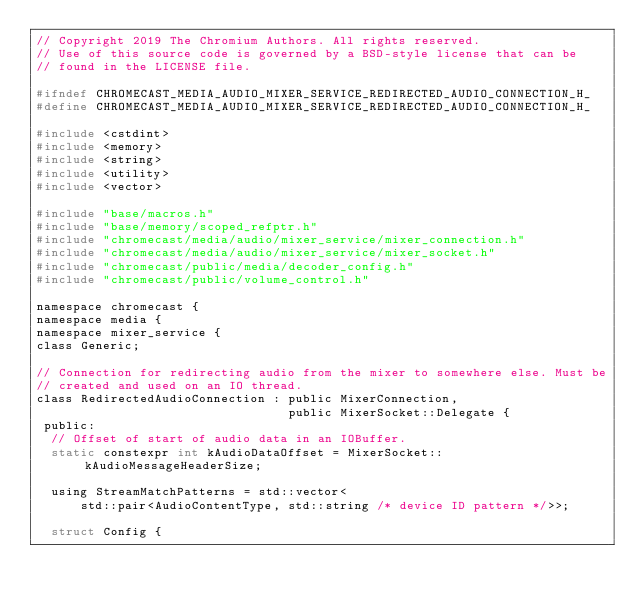Convert code to text. <code><loc_0><loc_0><loc_500><loc_500><_C_>// Copyright 2019 The Chromium Authors. All rights reserved.
// Use of this source code is governed by a BSD-style license that can be
// found in the LICENSE file.

#ifndef CHROMECAST_MEDIA_AUDIO_MIXER_SERVICE_REDIRECTED_AUDIO_CONNECTION_H_
#define CHROMECAST_MEDIA_AUDIO_MIXER_SERVICE_REDIRECTED_AUDIO_CONNECTION_H_

#include <cstdint>
#include <memory>
#include <string>
#include <utility>
#include <vector>

#include "base/macros.h"
#include "base/memory/scoped_refptr.h"
#include "chromecast/media/audio/mixer_service/mixer_connection.h"
#include "chromecast/media/audio/mixer_service/mixer_socket.h"
#include "chromecast/public/media/decoder_config.h"
#include "chromecast/public/volume_control.h"

namespace chromecast {
namespace media {
namespace mixer_service {
class Generic;

// Connection for redirecting audio from the mixer to somewhere else. Must be
// created and used on an IO thread.
class RedirectedAudioConnection : public MixerConnection,
                                  public MixerSocket::Delegate {
 public:
  // Offset of start of audio data in an IOBuffer.
  static constexpr int kAudioDataOffset = MixerSocket::kAudioMessageHeaderSize;

  using StreamMatchPatterns = std::vector<
      std::pair<AudioContentType, std::string /* device ID pattern */>>;

  struct Config {</code> 